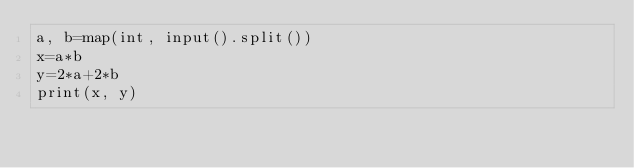Convert code to text. <code><loc_0><loc_0><loc_500><loc_500><_Python_>a, b=map(int, input().split())
x=a*b
y=2*a+2*b
print(x, y)
</code> 